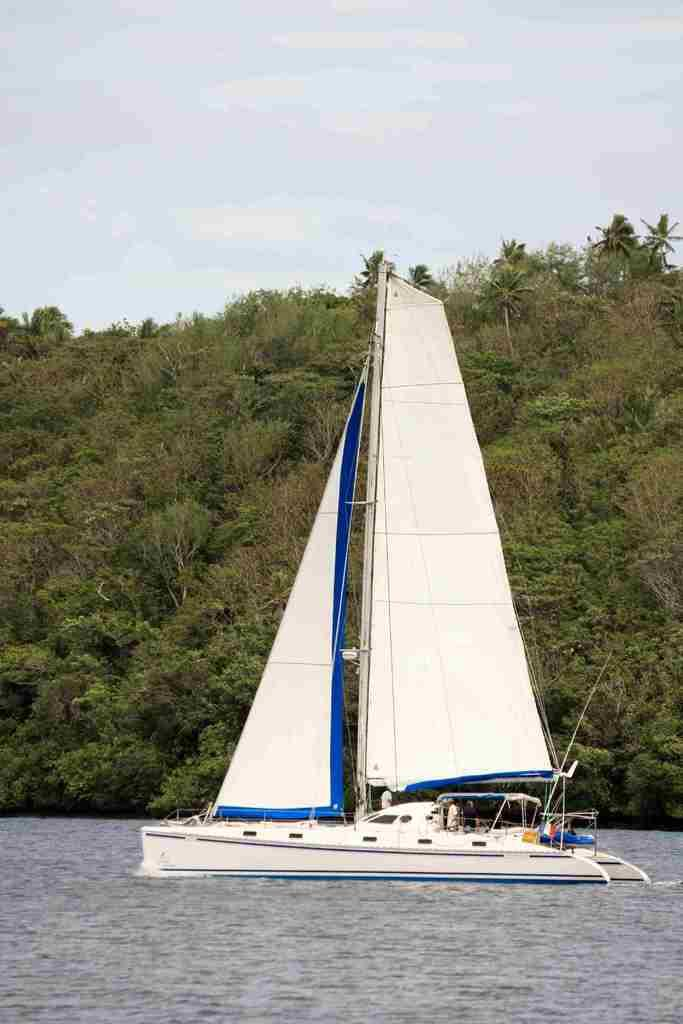What color is the boat in the image? The boat in the image is white. Where is the boat located? The boat is on the water. What can be seen in the background of the image? There are trees and the sky visible in the background of the image. Who is on the boat? There is a person on the boat. What else can be seen on the boat? There are other objects on the boat. What type of necklace is the person wearing on the boat? There is no necklace visible on the person in the image. 